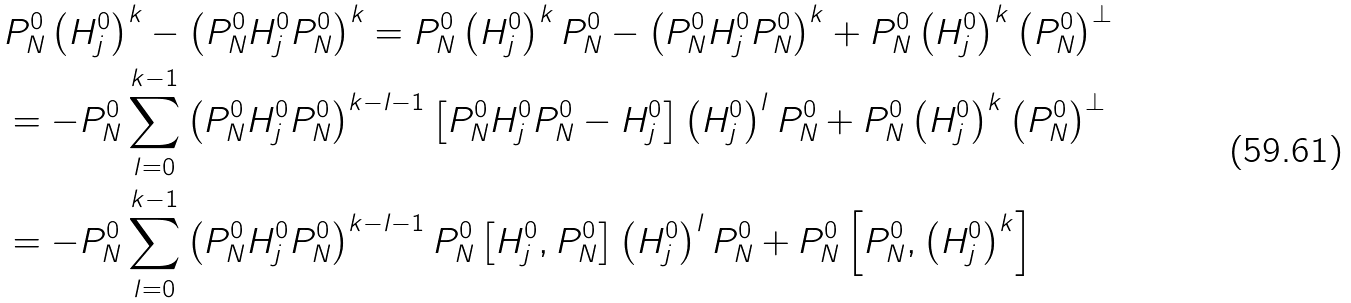Convert formula to latex. <formula><loc_0><loc_0><loc_500><loc_500>& P _ { N } ^ { 0 } \left ( H _ { j } ^ { 0 } \right ) ^ { k } - \left ( P _ { N } ^ { 0 } H _ { j } ^ { 0 } P _ { N } ^ { 0 } \right ) ^ { k } = P _ { N } ^ { 0 } \left ( H _ { j } ^ { 0 } \right ) ^ { k } P _ { N } ^ { 0 } - \left ( P _ { N } ^ { 0 } H _ { j } ^ { 0 } P _ { N } ^ { 0 } \right ) ^ { k } + P _ { N } ^ { 0 } \left ( H _ { j } ^ { 0 } \right ) ^ { k } \left ( P _ { N } ^ { 0 } \right ) ^ { \bot } \\ & = - P _ { N } ^ { 0 } \sum _ { l = 0 } ^ { k - 1 } \left ( P _ { N } ^ { 0 } H _ { j } ^ { 0 } P _ { N } ^ { 0 } \right ) ^ { k - l - 1 } \left [ P _ { N } ^ { 0 } H _ { j } ^ { 0 } P _ { N } ^ { 0 } - H _ { j } ^ { 0 } \right ] \left ( H _ { j } ^ { 0 } \right ) ^ { l } P _ { N } ^ { 0 } + P _ { N } ^ { 0 } \left ( H _ { j } ^ { 0 } \right ) ^ { k } \left ( P _ { N } ^ { 0 } \right ) ^ { \bot } \\ & = - P _ { N } ^ { 0 } \sum _ { l = 0 } ^ { k - 1 } \left ( P _ { N } ^ { 0 } H _ { j } ^ { 0 } P _ { N } ^ { 0 } \right ) ^ { k - l - 1 } P _ { N } ^ { 0 } \left [ H _ { j } ^ { 0 } , P _ { N } ^ { 0 } \right ] \left ( H _ { j } ^ { 0 } \right ) ^ { l } P _ { N } ^ { 0 } + P _ { N } ^ { 0 } \left [ P _ { N } ^ { 0 } , \left ( H _ { j } ^ { 0 } \right ) ^ { k } \right ]</formula> 